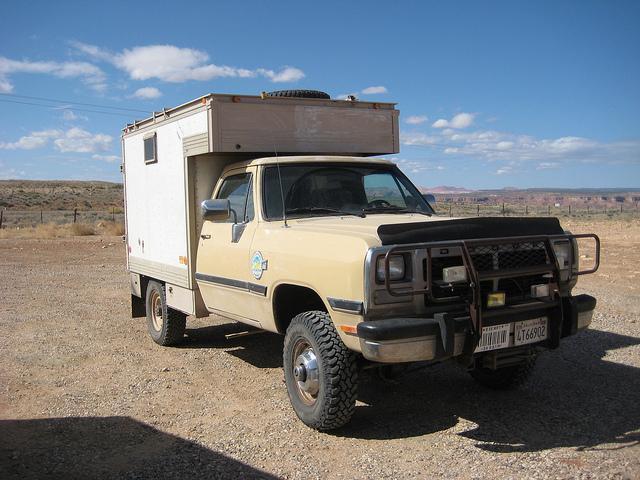How many shirtless people do you see ?
Give a very brief answer. 0. 